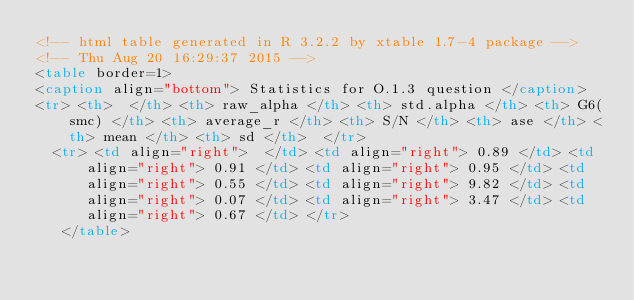Convert code to text. <code><loc_0><loc_0><loc_500><loc_500><_HTML_><!-- html table generated in R 3.2.2 by xtable 1.7-4 package -->
<!-- Thu Aug 20 16:29:37 2015 -->
<table border=1>
<caption align="bottom"> Statistics for O.1.3 question </caption>
<tr> <th>  </th> <th> raw_alpha </th> <th> std.alpha </th> <th> G6(smc) </th> <th> average_r </th> <th> S/N </th> <th> ase </th> <th> mean </th> <th> sd </th>  </tr>
  <tr> <td align="right">  </td> <td align="right"> 0.89 </td> <td align="right"> 0.91 </td> <td align="right"> 0.95 </td> <td align="right"> 0.55 </td> <td align="right"> 9.82 </td> <td align="right"> 0.07 </td> <td align="right"> 3.47 </td> <td align="right"> 0.67 </td> </tr>
   </table>
</code> 